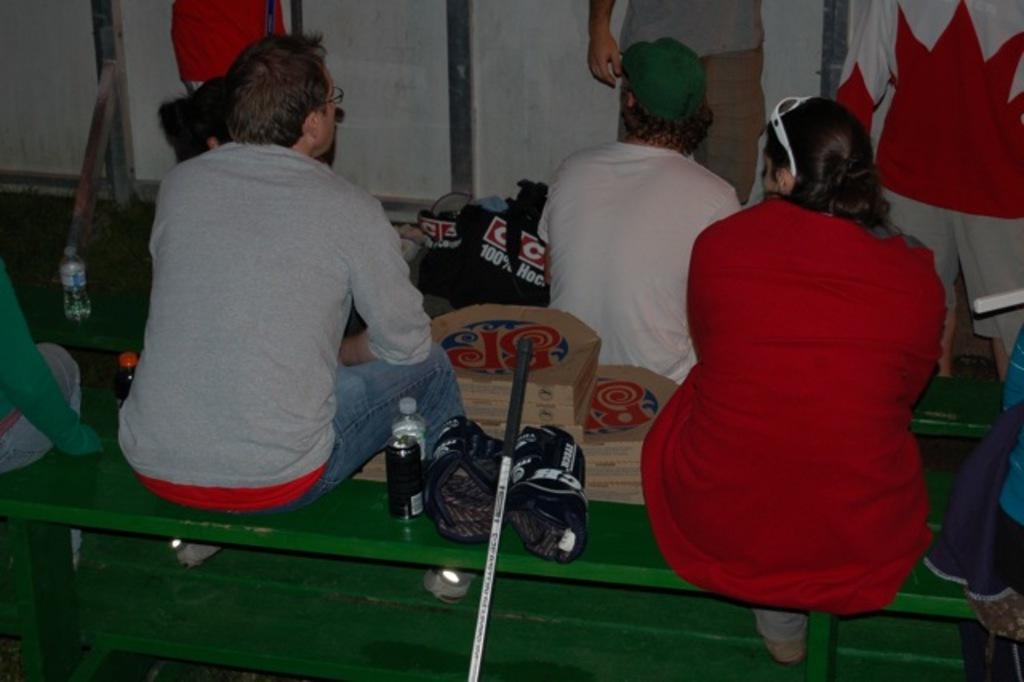Could you give a brief overview of what you see in this image? In this picture I can see few people seated an I can see few water bottles and a can and I can see few carton boxes and few people standing. 